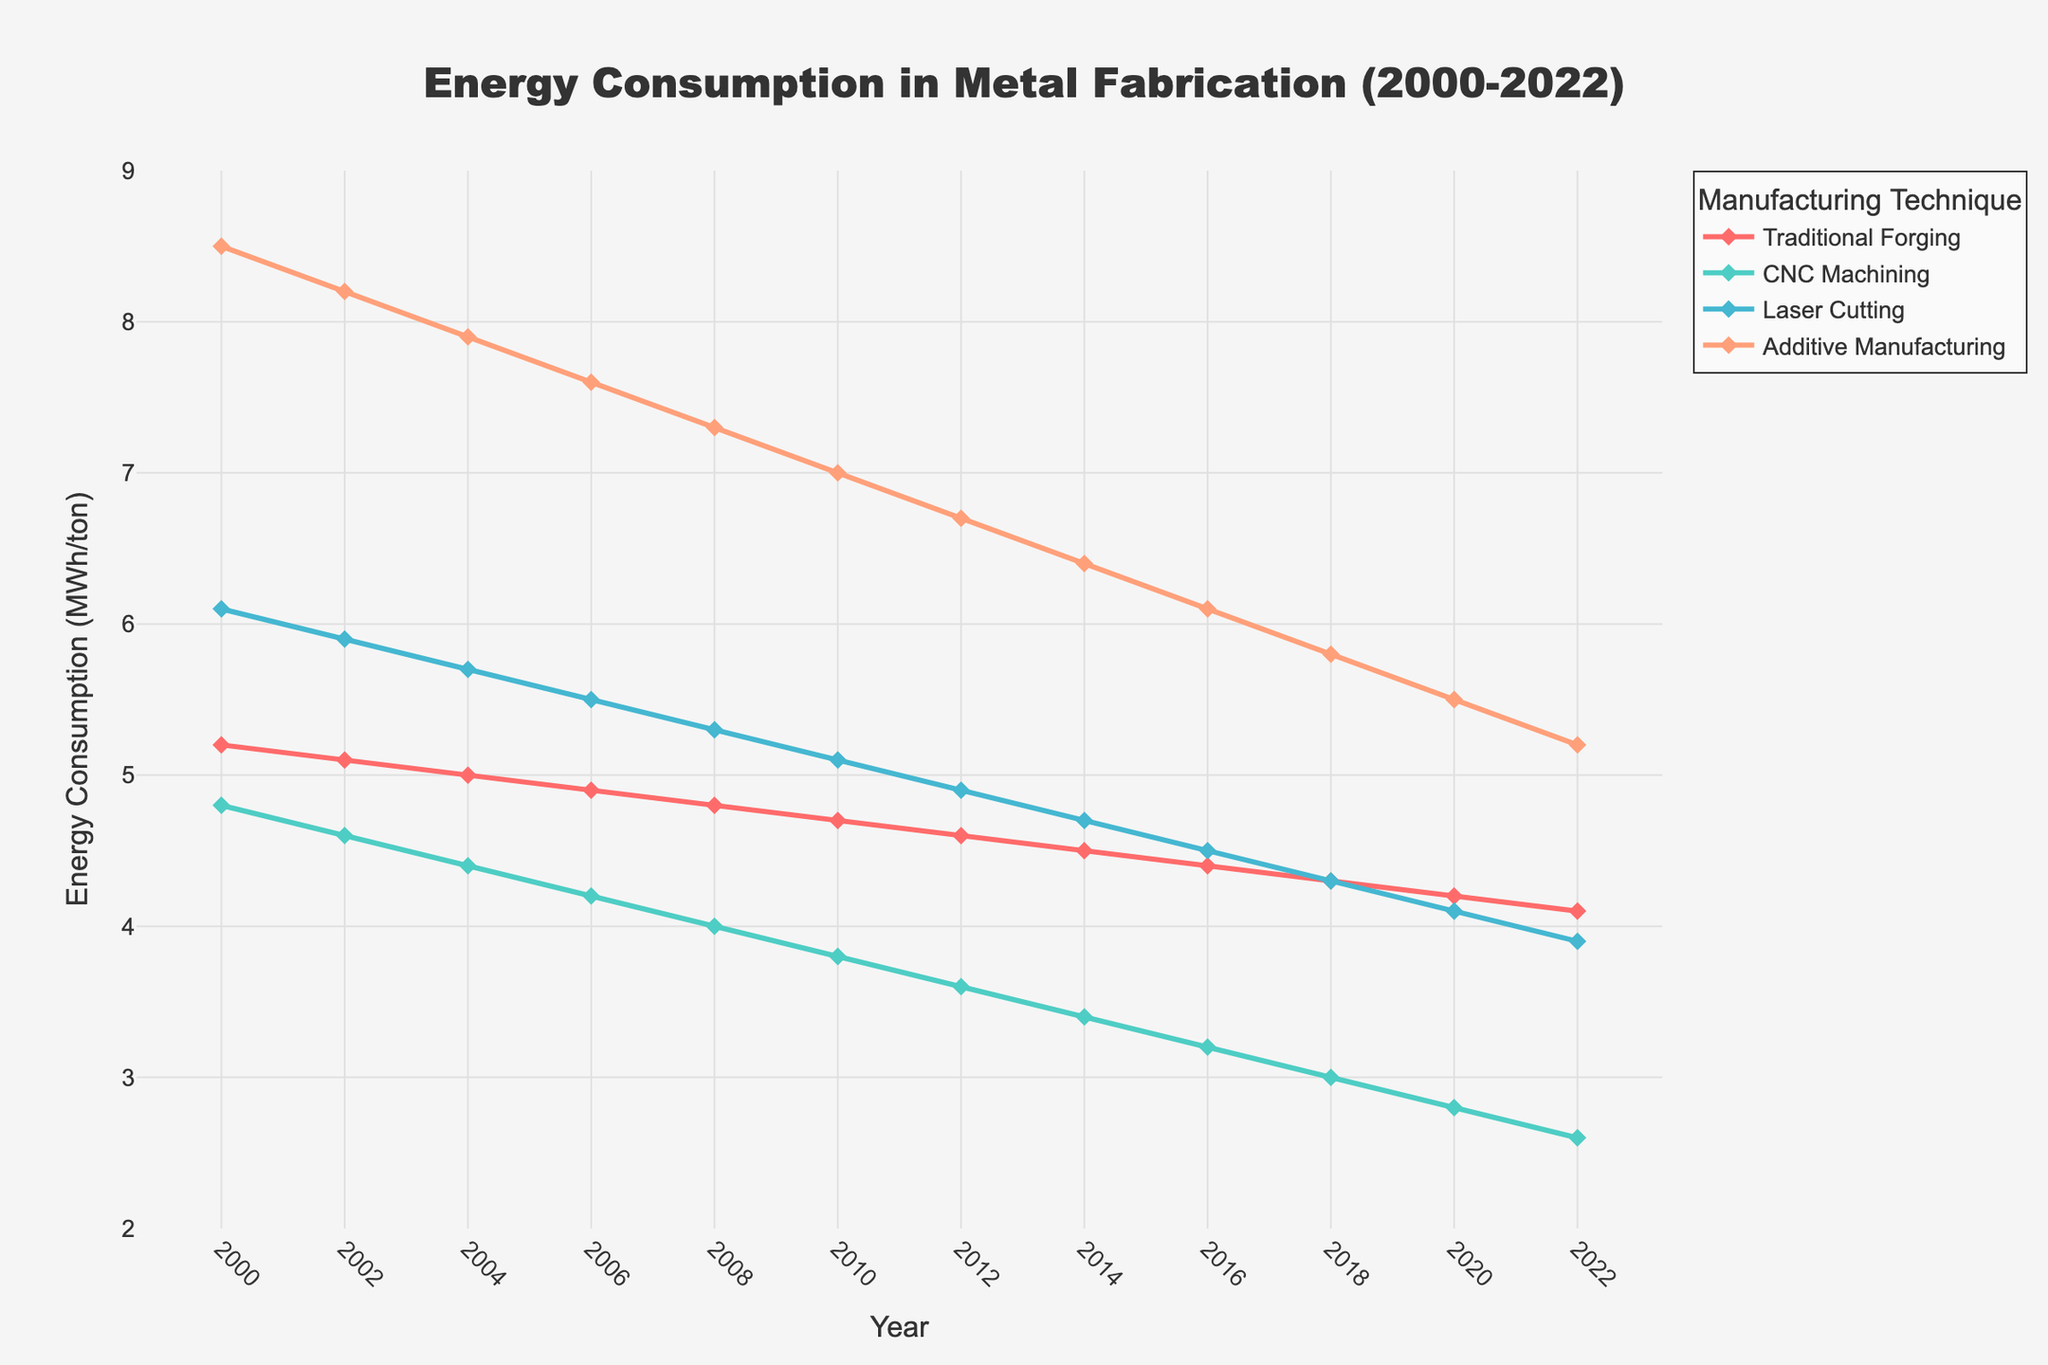what is the general trend of energy consumption for Traditional Forging from 2000 to 2022? The line for Traditional Forging shows a steady decline from 5.2 MWh/ton in 2000 down to 4.1 MWh/ton in 2022. The downward slope indicates a consistent reduction in energy consumption over the given period.
Answer: Steady decline Between which years did Laser Cutting experience the most significant decrease in energy consumption? Observing the Laser Cutting line, the most significant decrease occurs between 2004 and 2012, where it drops from 5.7 MWh/ton to 4.9 MWh/ton.
Answer: 2004 to 2012 Which technique had the lowest energy consumption in 2002 and what was the value? The line representing CNC Machining in 2002 is at 4.6 MWh/ton, which is below the levels of other techniques at that year, making it the lowest energy-consuming technique.
Answer: CNC Machining, 4.6 MWh/ton Compare the energy consumption of Additive Manufacturing and CNC Machining in 2020. In 2020, Additive Manufacturing shows an energy consumption of 5.5 MWh/ton while CNC Machining shows 2.8 MWh/ton. Additive Manufacturing consumes significantly more energy than CNC Machining.
Answer: Additive Manufacturing higher, 5.5 vs. 2.8 MWh/ton Which manufacturing technique shows the steepest decline in energy consumption over the observed period? CNC Machining shows the steepest decline with its line dropping from 4.8 MWh/ton in 2000 to 2.6 MWh/ton in 2022, making it the technique with the most significant reduction over time.
Answer: CNC Machining By how much did the energy consumption of Laser Cutting decrease from 2000 to 2022? In 2000, Laser Cutting consumed 6.1 MWh/ton and in 2022, it consumed 3.9 MWh/ton. The decrease is 6.1 - 3.9 = 2.2 MWh/ton.
Answer: 2.2 MWh/ton What is the mean value of energy consumption for Traditional Forging and CNC Machining in 2014? In 2014, Traditional Forging consumed 4.5 MWh/ton and CNC Machining consumed 3.4 MWh/ton. The mean value is (4.5 + 3.4) / 2 = 3.95 MWh/ton.
Answer: 3.95 MWh/ton Which technique showed the smallest change in energy consumption from 2018 to 2022? Traditional Forging's line shows the smallest change, decreasing only from 4.3 MWh/ton in 2018 to 4.1 MWh/ton in 2022, a difference of 0.2 MWh/ton.
Answer: Traditional Forging 